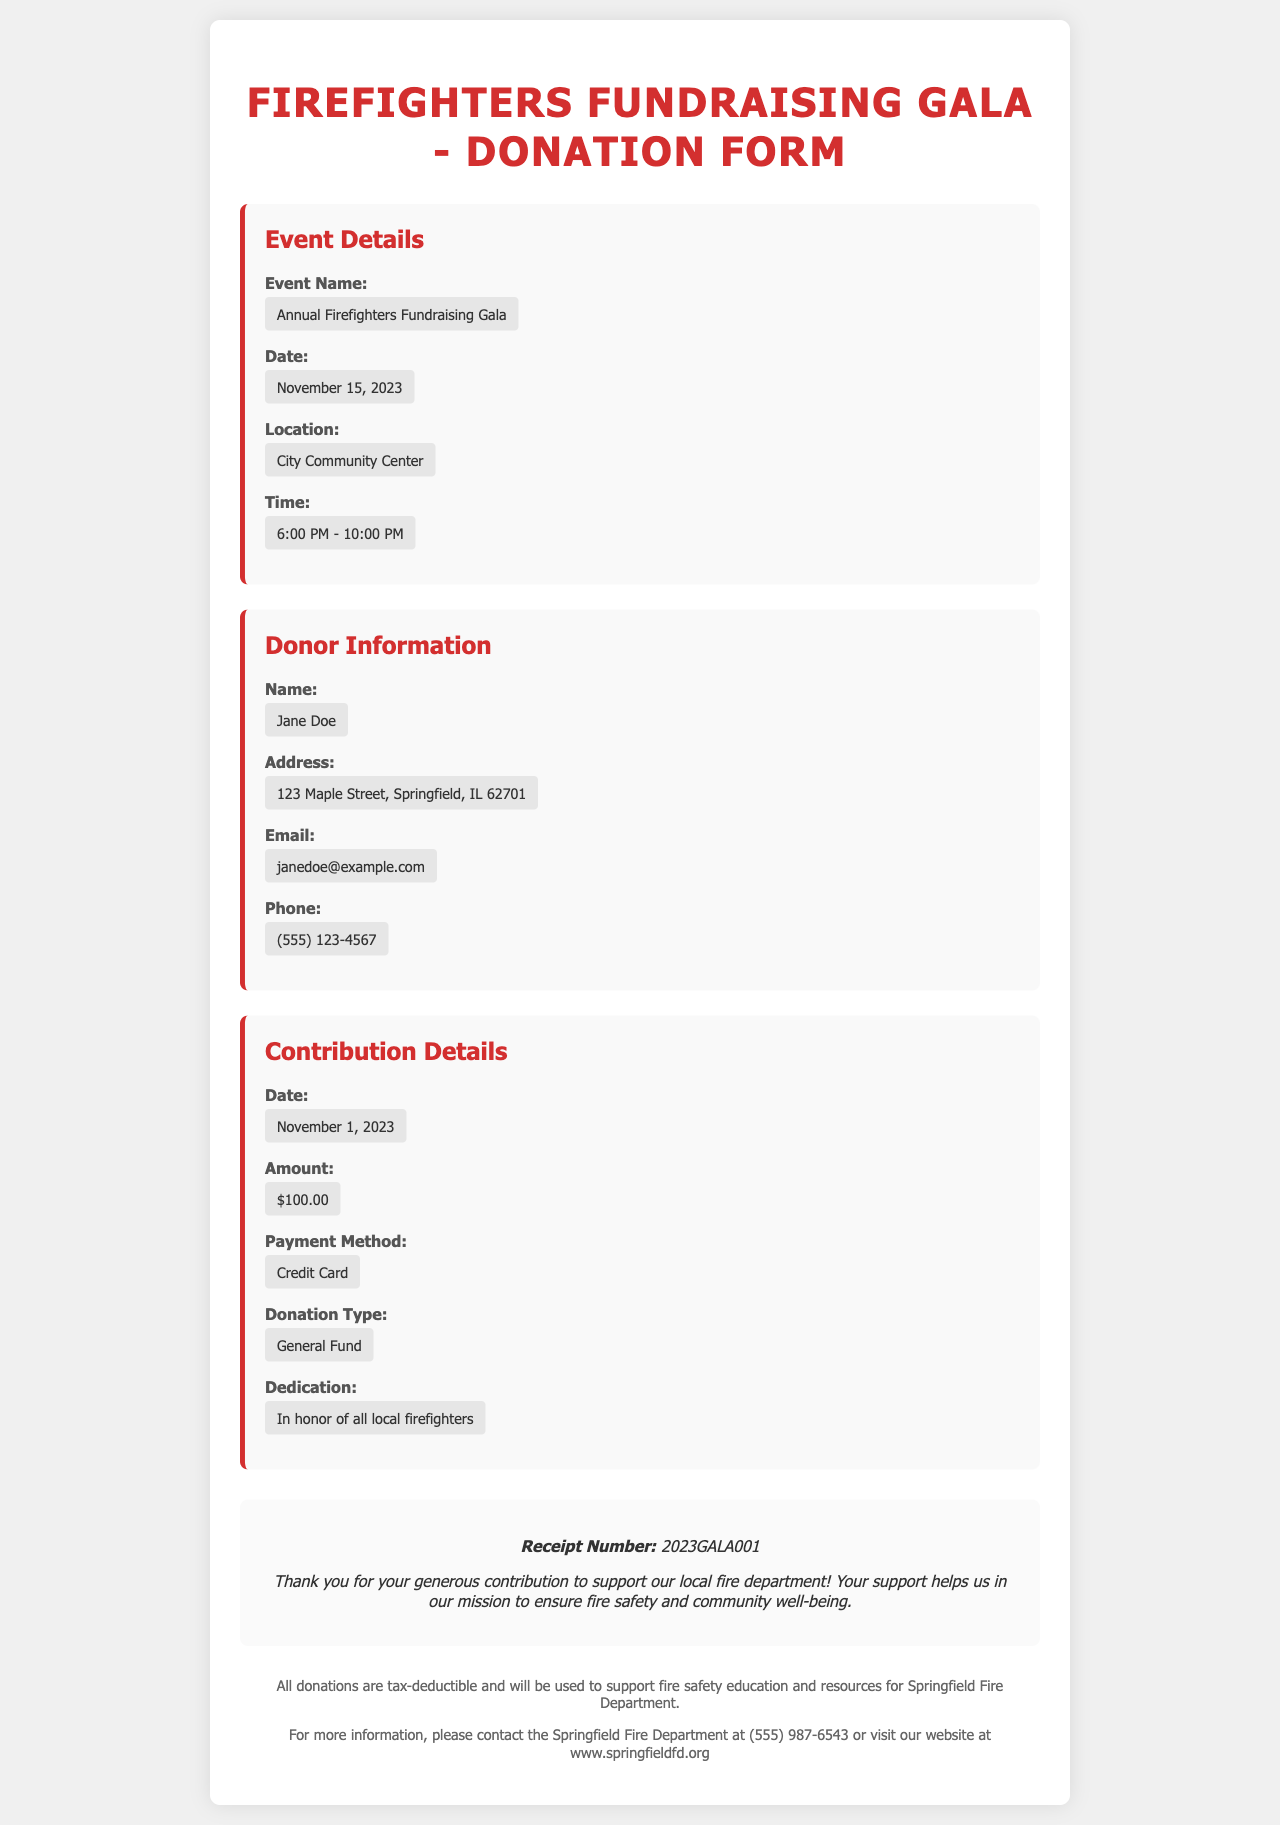What is the name of the event? The name of the event is mentioned in the heading of the document, which is "Annual Firefighters Fundraising Gala."
Answer: Annual Firefighters Fundraising Gala What is the date of the event? The date of the event is specified in the Event Details section, which states "November 15, 2023."
Answer: November 15, 2023 Who is the donor? The donor's name is provided in the Donor Information section, which shows "Jane Doe."
Answer: Jane Doe What is the donation amount? The donation amount is listed under Contribution Details, which indicates "$100.00."
Answer: $100.00 What type of donation was made? The type of donation is described in the Contribution Details, marked as "General Fund."
Answer: General Fund What is the receipt number? The receipt number is stated in the acknowledgment section, which shows "2023GALA001."
Answer: 2023GALA001 What payment method was used? The payment method is detailed in the Contribution Details section, which indicates "Credit Card."
Answer: Credit Card In honor of whom was the donation made? The dedication of the donation is specified in the Contribution Details, stating "In honor of all local firefighters."
Answer: In honor of all local firefighters What is the location of the event? The location of the event is mentioned in the Event Details section, which states "City Community Center."
Answer: City Community Center 